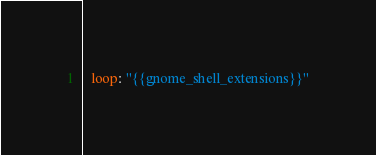<code> <loc_0><loc_0><loc_500><loc_500><_YAML_>  loop: "{{gnome_shell_extensions}}"
</code> 